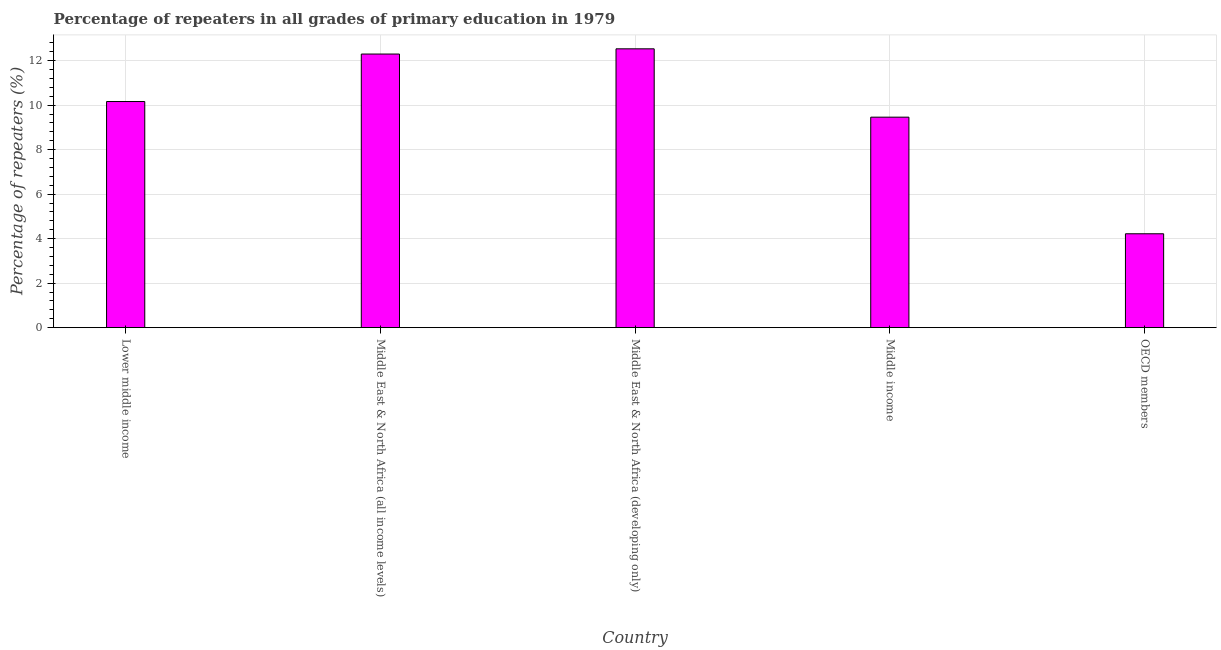Does the graph contain grids?
Give a very brief answer. Yes. What is the title of the graph?
Your response must be concise. Percentage of repeaters in all grades of primary education in 1979. What is the label or title of the Y-axis?
Keep it short and to the point. Percentage of repeaters (%). What is the percentage of repeaters in primary education in Middle East & North Africa (all income levels)?
Ensure brevity in your answer.  12.3. Across all countries, what is the maximum percentage of repeaters in primary education?
Your answer should be compact. 12.53. Across all countries, what is the minimum percentage of repeaters in primary education?
Your answer should be very brief. 4.22. In which country was the percentage of repeaters in primary education maximum?
Your answer should be very brief. Middle East & North Africa (developing only). In which country was the percentage of repeaters in primary education minimum?
Ensure brevity in your answer.  OECD members. What is the sum of the percentage of repeaters in primary education?
Offer a terse response. 48.67. What is the difference between the percentage of repeaters in primary education in Lower middle income and OECD members?
Offer a terse response. 5.94. What is the average percentage of repeaters in primary education per country?
Ensure brevity in your answer.  9.73. What is the median percentage of repeaters in primary education?
Your response must be concise. 10.16. What is the ratio of the percentage of repeaters in primary education in Middle East & North Africa (all income levels) to that in OECD members?
Make the answer very short. 2.91. Is the difference between the percentage of repeaters in primary education in Middle East & North Africa (all income levels) and Middle income greater than the difference between any two countries?
Offer a very short reply. No. What is the difference between the highest and the second highest percentage of repeaters in primary education?
Give a very brief answer. 0.23. What is the difference between the highest and the lowest percentage of repeaters in primary education?
Make the answer very short. 8.31. In how many countries, is the percentage of repeaters in primary education greater than the average percentage of repeaters in primary education taken over all countries?
Your response must be concise. 3. How many countries are there in the graph?
Your response must be concise. 5. Are the values on the major ticks of Y-axis written in scientific E-notation?
Provide a succinct answer. No. What is the Percentage of repeaters (%) of Lower middle income?
Give a very brief answer. 10.16. What is the Percentage of repeaters (%) in Middle East & North Africa (all income levels)?
Your answer should be very brief. 12.3. What is the Percentage of repeaters (%) of Middle East & North Africa (developing only)?
Provide a succinct answer. 12.53. What is the Percentage of repeaters (%) in Middle income?
Offer a very short reply. 9.46. What is the Percentage of repeaters (%) in OECD members?
Make the answer very short. 4.22. What is the difference between the Percentage of repeaters (%) in Lower middle income and Middle East & North Africa (all income levels)?
Your response must be concise. -2.13. What is the difference between the Percentage of repeaters (%) in Lower middle income and Middle East & North Africa (developing only)?
Ensure brevity in your answer.  -2.37. What is the difference between the Percentage of repeaters (%) in Lower middle income and Middle income?
Make the answer very short. 0.7. What is the difference between the Percentage of repeaters (%) in Lower middle income and OECD members?
Give a very brief answer. 5.94. What is the difference between the Percentage of repeaters (%) in Middle East & North Africa (all income levels) and Middle East & North Africa (developing only)?
Provide a succinct answer. -0.23. What is the difference between the Percentage of repeaters (%) in Middle East & North Africa (all income levels) and Middle income?
Provide a succinct answer. 2.84. What is the difference between the Percentage of repeaters (%) in Middle East & North Africa (all income levels) and OECD members?
Ensure brevity in your answer.  8.08. What is the difference between the Percentage of repeaters (%) in Middle East & North Africa (developing only) and Middle income?
Ensure brevity in your answer.  3.07. What is the difference between the Percentage of repeaters (%) in Middle East & North Africa (developing only) and OECD members?
Your answer should be very brief. 8.31. What is the difference between the Percentage of repeaters (%) in Middle income and OECD members?
Keep it short and to the point. 5.24. What is the ratio of the Percentage of repeaters (%) in Lower middle income to that in Middle East & North Africa (all income levels)?
Your answer should be very brief. 0.83. What is the ratio of the Percentage of repeaters (%) in Lower middle income to that in Middle East & North Africa (developing only)?
Your answer should be compact. 0.81. What is the ratio of the Percentage of repeaters (%) in Lower middle income to that in Middle income?
Provide a succinct answer. 1.07. What is the ratio of the Percentage of repeaters (%) in Lower middle income to that in OECD members?
Your response must be concise. 2.41. What is the ratio of the Percentage of repeaters (%) in Middle East & North Africa (all income levels) to that in Middle East & North Africa (developing only)?
Provide a succinct answer. 0.98. What is the ratio of the Percentage of repeaters (%) in Middle East & North Africa (all income levels) to that in Middle income?
Your answer should be compact. 1.3. What is the ratio of the Percentage of repeaters (%) in Middle East & North Africa (all income levels) to that in OECD members?
Keep it short and to the point. 2.91. What is the ratio of the Percentage of repeaters (%) in Middle East & North Africa (developing only) to that in Middle income?
Provide a short and direct response. 1.32. What is the ratio of the Percentage of repeaters (%) in Middle East & North Africa (developing only) to that in OECD members?
Offer a terse response. 2.97. What is the ratio of the Percentage of repeaters (%) in Middle income to that in OECD members?
Your answer should be very brief. 2.24. 